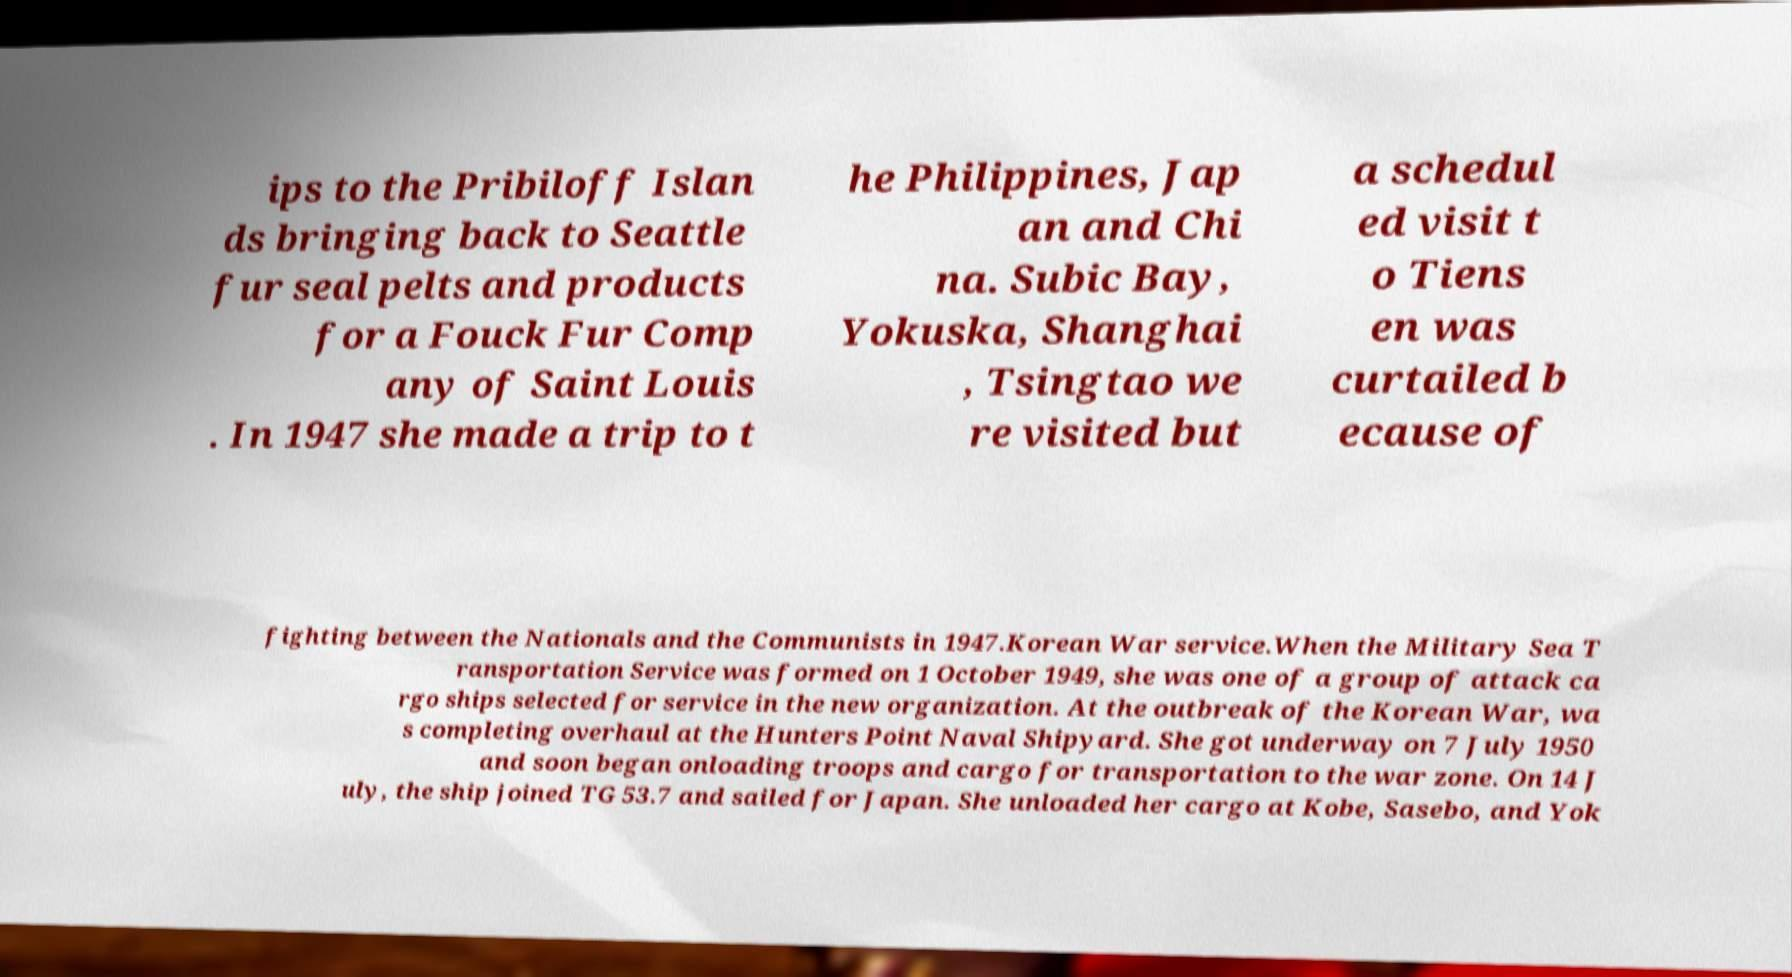For documentation purposes, I need the text within this image transcribed. Could you provide that? ips to the Pribiloff Islan ds bringing back to Seattle fur seal pelts and products for a Fouck Fur Comp any of Saint Louis . In 1947 she made a trip to t he Philippines, Jap an and Chi na. Subic Bay, Yokuska, Shanghai , Tsingtao we re visited but a schedul ed visit t o Tiens en was curtailed b ecause of fighting between the Nationals and the Communists in 1947.Korean War service.When the Military Sea T ransportation Service was formed on 1 October 1949, she was one of a group of attack ca rgo ships selected for service in the new organization. At the outbreak of the Korean War, wa s completing overhaul at the Hunters Point Naval Shipyard. She got underway on 7 July 1950 and soon began onloading troops and cargo for transportation to the war zone. On 14 J uly, the ship joined TG 53.7 and sailed for Japan. She unloaded her cargo at Kobe, Sasebo, and Yok 